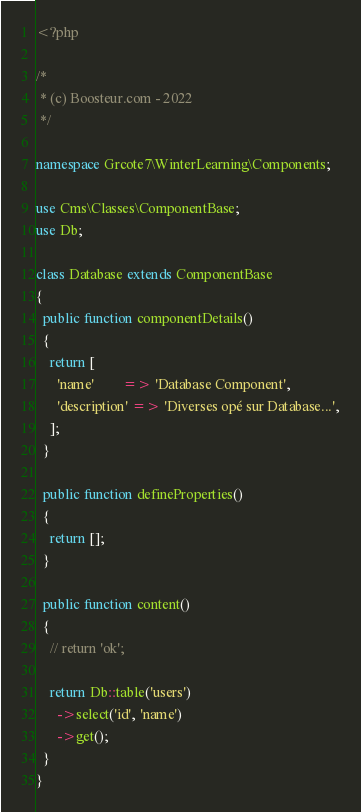<code> <loc_0><loc_0><loc_500><loc_500><_PHP_><?php

/*
 * (c) Boosteur.com - 2022
 */

namespace Grcote7\WinterLearning\Components;

use Cms\Classes\ComponentBase;
use Db;

class Database extends ComponentBase
{
  public function componentDetails()
  {
    return [
      'name'        => 'Database Component',
      'description' => 'Diverses opé sur Database...',
    ];
  }

  public function defineProperties()
  {
    return [];
  }

  public function content()
  {
    // return 'ok';

    return Db::table('users')
      ->select('id', 'name')
      ->get();
  }
}
</code> 